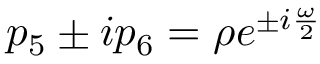Convert formula to latex. <formula><loc_0><loc_0><loc_500><loc_500>p _ { 5 } \pm i p _ { 6 } = \rho e ^ { \pm i \frac { \omega } { 2 } }</formula> 